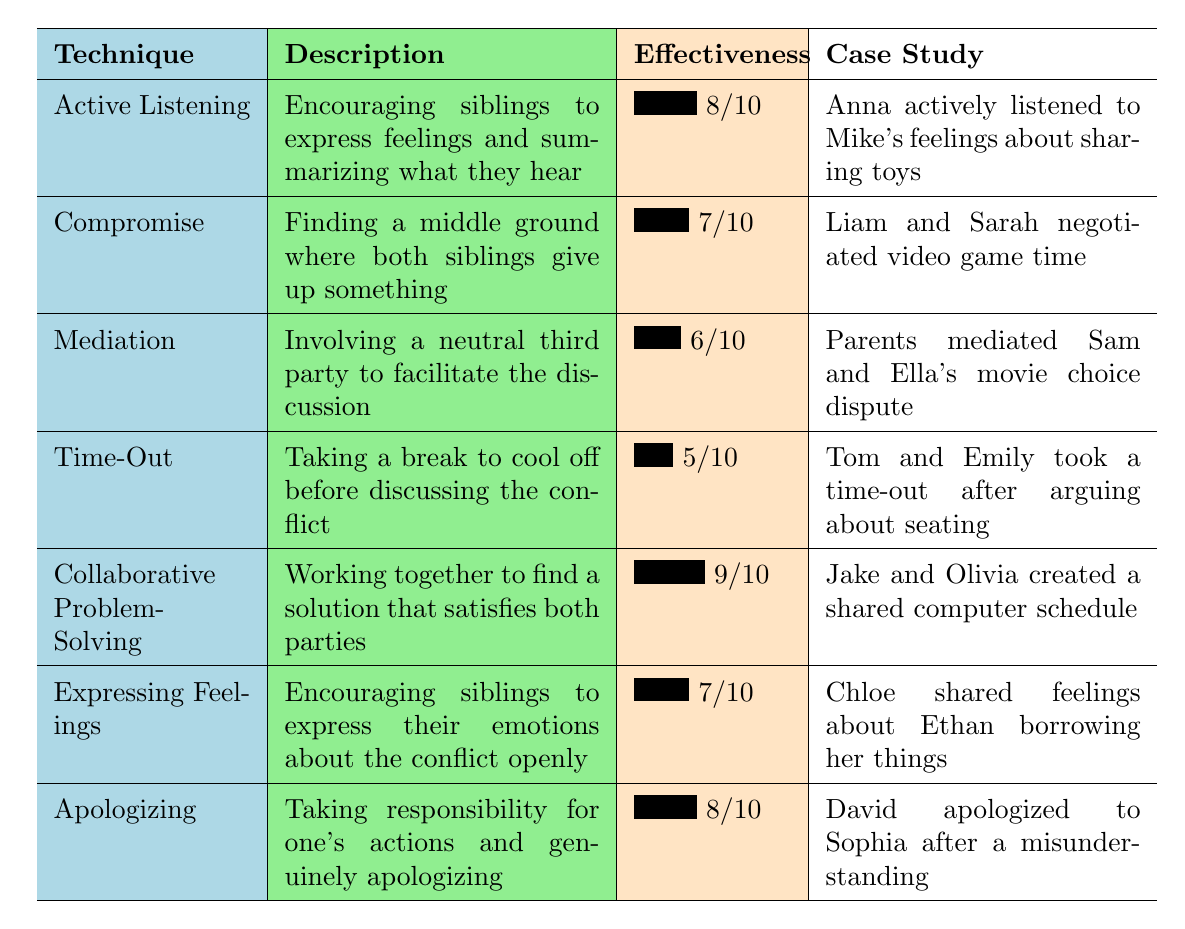What is the highest effectiveness rating for a conflict resolution technique? By examining the effectiveness ratings in the table, we see the highest rating is 9/10 for the technique "Collaborative Problem-Solving."
Answer: 9/10 Who were the siblings involved in the "Active Listening" technique? The table shows that the siblings involved in the "Active Listening" technique are Anna and Mike.
Answer: Anna and Mike What is the effectiveness rating for "Time-Out"? The effectiveness rating for "Time-Out" listed in the table is 5/10.
Answer: 5/10 Which conflict resolution technique had the case study involving parents? The technique that had parents involved in the case study is "Mediation," where parents facilitated the discussion between Sam and Ella.
Answer: Mediation What is the average effectiveness rating of the conflict resolution techniques listed? To find the average, sum the ratings of all techniques: (8 + 7 + 6 + 5 + 9 + 7 + 8) = 50. There are 7 techniques, so the average is 50/7 ≈ 7.14.
Answer: Approximately 7.14 Is "Expressing Feelings" more effective than "Time-Out"? "Expressing Feelings" has a rating of 7/10, and "Time-Out" has a rating of 5/10. Since 7 > 5, we conclude that "Expressing Feelings" is indeed more effective.
Answer: Yes Based on the table, which technique involves giving up something from both siblings? The technique that involves giving up something from both siblings is "Compromise," as it focuses on finding a middle ground.
Answer: Compromise What percentage of techniques have an effectiveness rating of 7 or higher? There are 7 techniques total. The techniques with ratings of 7 or higher are "Active Listening," "Compromise," "Collaborative Problem-Solving," "Expressing Feelings," and "Apologizing," totaling 5 techniques. The percentage is (5/7) * 100 ≈ 71.43%.
Answer: Approximately 71.43% How many case studies involved siblings named Jake or Olivia? The case study involving siblings named Jake and Olivia refers to "Collaborative Problem-Solving," so there is 1 case study involving them.
Answer: 1 In which conflict resolution technique were the siblings negotiating video game time? The technique in which the siblings negotiated video game time is "Compromise," as described in the case study involving Liam and Sarah.
Answer: Compromise 